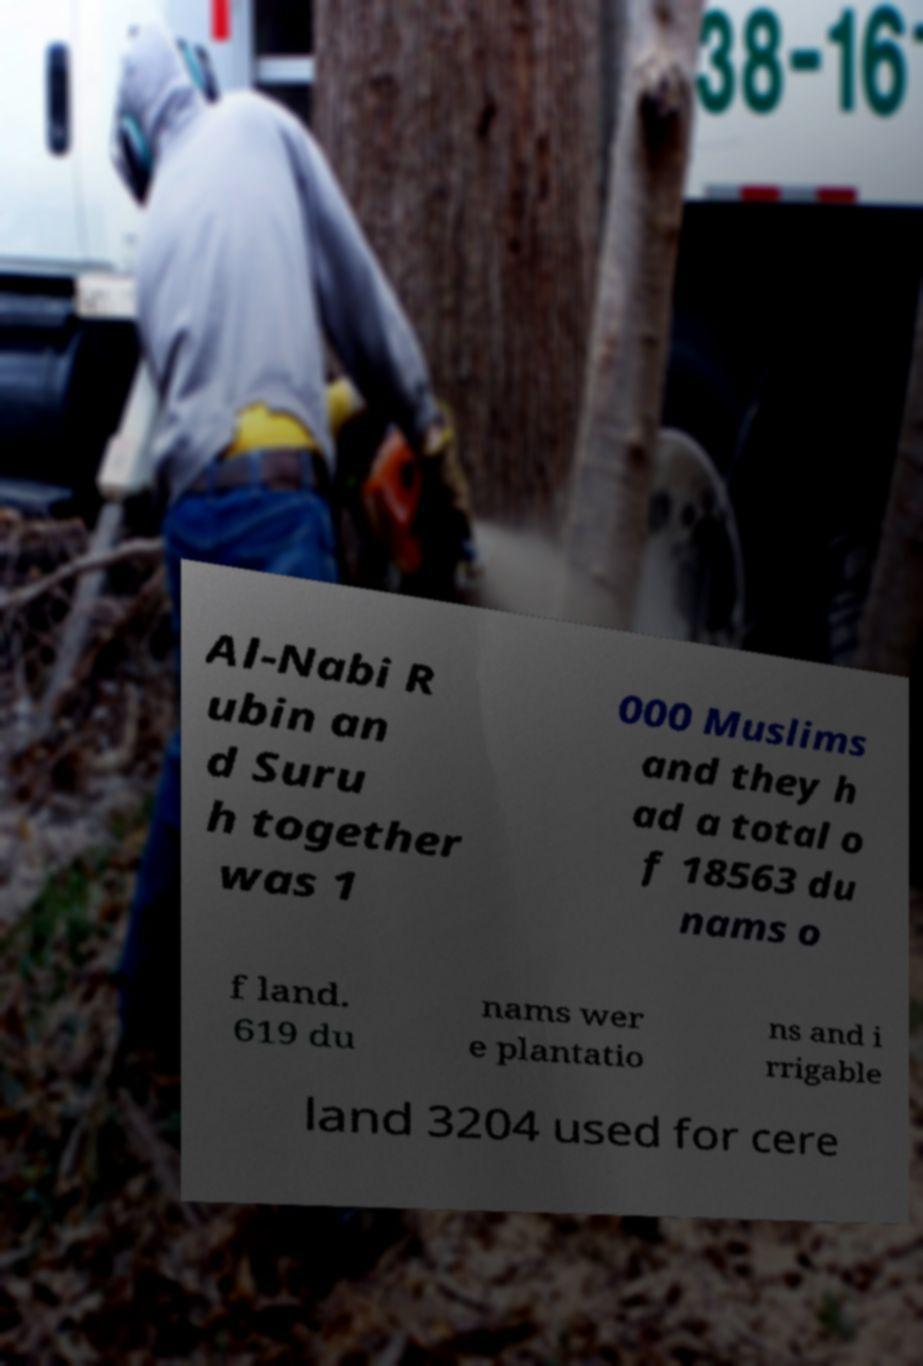Can you read and provide the text displayed in the image?This photo seems to have some interesting text. Can you extract and type it out for me? Al-Nabi R ubin an d Suru h together was 1 000 Muslims and they h ad a total o f 18563 du nams o f land. 619 du nams wer e plantatio ns and i rrigable land 3204 used for cere 